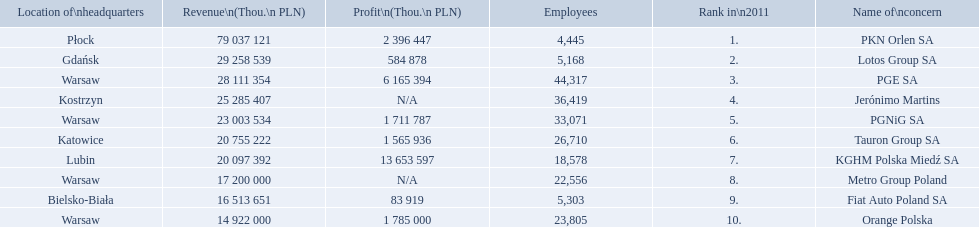What company has 28 111 354 thou.in revenue? PGE SA. What revenue does lotus group sa have? 29 258 539. Who has the next highest revenue than lotus group sa? PKN Orlen SA. 